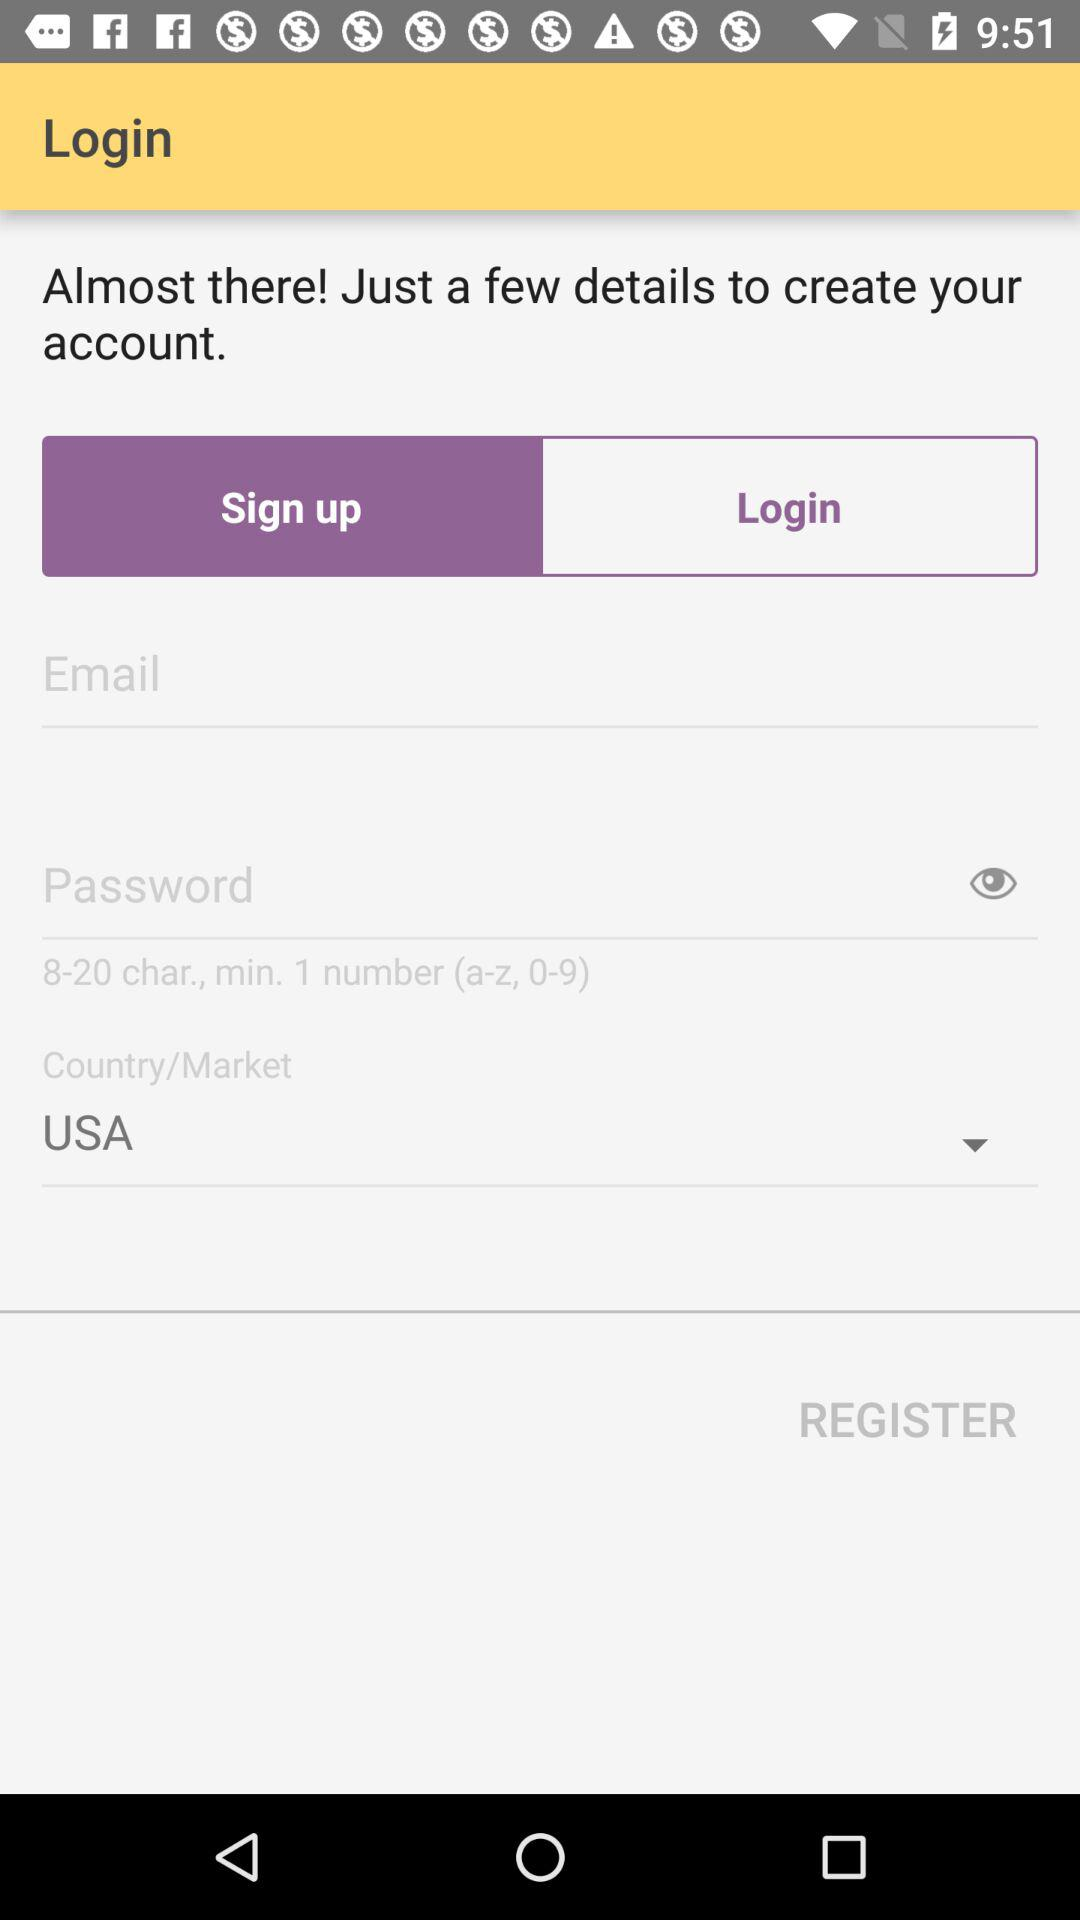Which country is selected? The selected country is USA. 